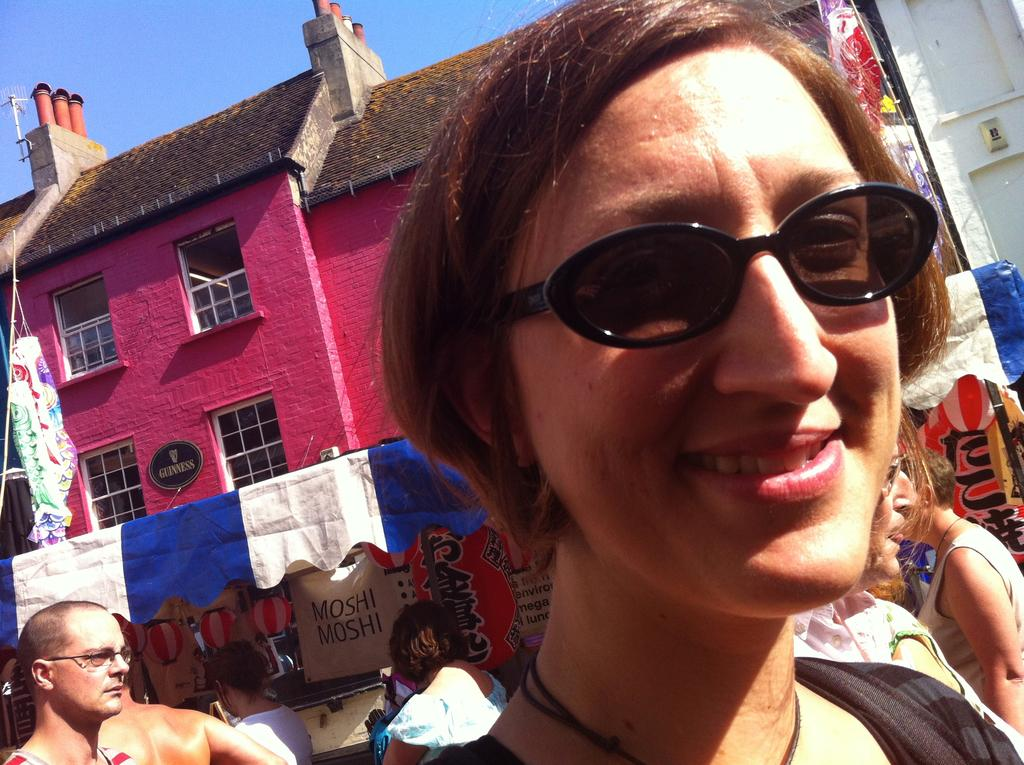Who is the main subject in the image? There is a girl in the image. What is the girl's expression? The girl is smiling. Can you describe the people behind the girl? There are people behind the girl, but their specific features are not mentioned in the facts. What can be seen in the background of the image? There is a tent, a building, and the sky visible in the background of the image. What type of sponge is the girl using to scrub the potato in the image? There is no sponge or potato present in the image. What is being served for dinner in the image? The facts do not mention any dinner or food being served in the image. 